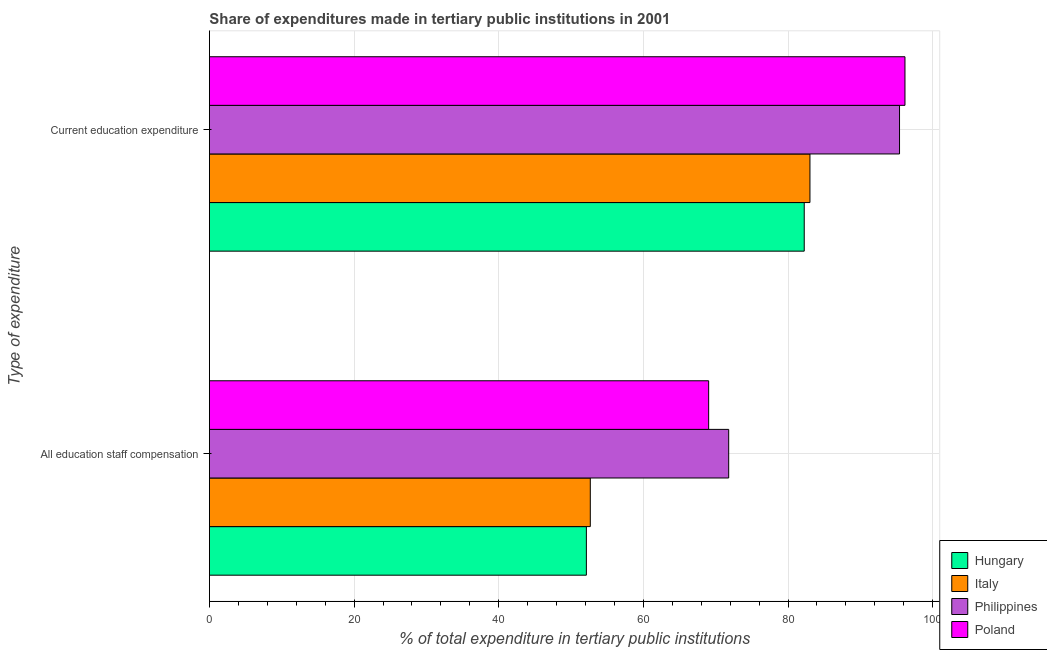How many different coloured bars are there?
Offer a terse response. 4. How many groups of bars are there?
Your answer should be compact. 2. How many bars are there on the 1st tick from the top?
Your response must be concise. 4. What is the label of the 2nd group of bars from the top?
Provide a succinct answer. All education staff compensation. What is the expenditure in staff compensation in Poland?
Offer a terse response. 69.02. Across all countries, what is the maximum expenditure in education?
Offer a very short reply. 96.16. Across all countries, what is the minimum expenditure in education?
Provide a short and direct response. 82.24. In which country was the expenditure in education minimum?
Make the answer very short. Hungary. What is the total expenditure in education in the graph?
Offer a very short reply. 356.84. What is the difference between the expenditure in education in Italy and that in Philippines?
Provide a short and direct response. -12.39. What is the difference between the expenditure in education in Hungary and the expenditure in staff compensation in Poland?
Offer a terse response. 13.22. What is the average expenditure in education per country?
Give a very brief answer. 89.21. What is the difference between the expenditure in staff compensation and expenditure in education in Hungary?
Your answer should be compact. -30.12. In how many countries, is the expenditure in education greater than 16 %?
Keep it short and to the point. 4. What is the ratio of the expenditure in staff compensation in Philippines to that in Poland?
Your response must be concise. 1.04. In how many countries, is the expenditure in staff compensation greater than the average expenditure in staff compensation taken over all countries?
Provide a succinct answer. 2. How many bars are there?
Provide a succinct answer. 8. What is the difference between two consecutive major ticks on the X-axis?
Provide a short and direct response. 20. Are the values on the major ticks of X-axis written in scientific E-notation?
Give a very brief answer. No. Does the graph contain any zero values?
Provide a succinct answer. No. How many legend labels are there?
Your answer should be very brief. 4. How are the legend labels stacked?
Your answer should be very brief. Vertical. What is the title of the graph?
Make the answer very short. Share of expenditures made in tertiary public institutions in 2001. What is the label or title of the X-axis?
Offer a terse response. % of total expenditure in tertiary public institutions. What is the label or title of the Y-axis?
Your answer should be very brief. Type of expenditure. What is the % of total expenditure in tertiary public institutions in Hungary in All education staff compensation?
Make the answer very short. 52.12. What is the % of total expenditure in tertiary public institutions of Italy in All education staff compensation?
Make the answer very short. 52.66. What is the % of total expenditure in tertiary public institutions of Philippines in All education staff compensation?
Give a very brief answer. 71.79. What is the % of total expenditure in tertiary public institutions in Poland in All education staff compensation?
Provide a succinct answer. 69.02. What is the % of total expenditure in tertiary public institutions in Hungary in Current education expenditure?
Your answer should be very brief. 82.24. What is the % of total expenditure in tertiary public institutions of Italy in Current education expenditure?
Provide a short and direct response. 83.03. What is the % of total expenditure in tertiary public institutions of Philippines in Current education expenditure?
Make the answer very short. 95.41. What is the % of total expenditure in tertiary public institutions of Poland in Current education expenditure?
Offer a very short reply. 96.16. Across all Type of expenditure, what is the maximum % of total expenditure in tertiary public institutions in Hungary?
Offer a very short reply. 82.24. Across all Type of expenditure, what is the maximum % of total expenditure in tertiary public institutions in Italy?
Provide a succinct answer. 83.03. Across all Type of expenditure, what is the maximum % of total expenditure in tertiary public institutions of Philippines?
Provide a short and direct response. 95.41. Across all Type of expenditure, what is the maximum % of total expenditure in tertiary public institutions in Poland?
Your answer should be very brief. 96.16. Across all Type of expenditure, what is the minimum % of total expenditure in tertiary public institutions of Hungary?
Offer a very short reply. 52.12. Across all Type of expenditure, what is the minimum % of total expenditure in tertiary public institutions of Italy?
Your response must be concise. 52.66. Across all Type of expenditure, what is the minimum % of total expenditure in tertiary public institutions of Philippines?
Your answer should be very brief. 71.79. Across all Type of expenditure, what is the minimum % of total expenditure in tertiary public institutions in Poland?
Make the answer very short. 69.02. What is the total % of total expenditure in tertiary public institutions of Hungary in the graph?
Make the answer very short. 134.35. What is the total % of total expenditure in tertiary public institutions in Italy in the graph?
Provide a short and direct response. 135.69. What is the total % of total expenditure in tertiary public institutions of Philippines in the graph?
Your response must be concise. 167.21. What is the total % of total expenditure in tertiary public institutions of Poland in the graph?
Your answer should be compact. 165.19. What is the difference between the % of total expenditure in tertiary public institutions in Hungary in All education staff compensation and that in Current education expenditure?
Make the answer very short. -30.12. What is the difference between the % of total expenditure in tertiary public institutions in Italy in All education staff compensation and that in Current education expenditure?
Your response must be concise. -30.37. What is the difference between the % of total expenditure in tertiary public institutions in Philippines in All education staff compensation and that in Current education expenditure?
Ensure brevity in your answer.  -23.62. What is the difference between the % of total expenditure in tertiary public institutions of Poland in All education staff compensation and that in Current education expenditure?
Offer a terse response. -27.14. What is the difference between the % of total expenditure in tertiary public institutions of Hungary in All education staff compensation and the % of total expenditure in tertiary public institutions of Italy in Current education expenditure?
Provide a short and direct response. -30.91. What is the difference between the % of total expenditure in tertiary public institutions in Hungary in All education staff compensation and the % of total expenditure in tertiary public institutions in Philippines in Current education expenditure?
Keep it short and to the point. -43.3. What is the difference between the % of total expenditure in tertiary public institutions in Hungary in All education staff compensation and the % of total expenditure in tertiary public institutions in Poland in Current education expenditure?
Your response must be concise. -44.05. What is the difference between the % of total expenditure in tertiary public institutions of Italy in All education staff compensation and the % of total expenditure in tertiary public institutions of Philippines in Current education expenditure?
Your answer should be compact. -42.75. What is the difference between the % of total expenditure in tertiary public institutions of Italy in All education staff compensation and the % of total expenditure in tertiary public institutions of Poland in Current education expenditure?
Make the answer very short. -43.5. What is the difference between the % of total expenditure in tertiary public institutions of Philippines in All education staff compensation and the % of total expenditure in tertiary public institutions of Poland in Current education expenditure?
Ensure brevity in your answer.  -24.37. What is the average % of total expenditure in tertiary public institutions of Hungary per Type of expenditure?
Offer a very short reply. 67.18. What is the average % of total expenditure in tertiary public institutions of Italy per Type of expenditure?
Your answer should be compact. 67.84. What is the average % of total expenditure in tertiary public institutions of Philippines per Type of expenditure?
Give a very brief answer. 83.6. What is the average % of total expenditure in tertiary public institutions in Poland per Type of expenditure?
Provide a short and direct response. 82.59. What is the difference between the % of total expenditure in tertiary public institutions in Hungary and % of total expenditure in tertiary public institutions in Italy in All education staff compensation?
Offer a terse response. -0.54. What is the difference between the % of total expenditure in tertiary public institutions of Hungary and % of total expenditure in tertiary public institutions of Philippines in All education staff compensation?
Offer a very short reply. -19.67. What is the difference between the % of total expenditure in tertiary public institutions of Hungary and % of total expenditure in tertiary public institutions of Poland in All education staff compensation?
Give a very brief answer. -16.9. What is the difference between the % of total expenditure in tertiary public institutions of Italy and % of total expenditure in tertiary public institutions of Philippines in All education staff compensation?
Ensure brevity in your answer.  -19.13. What is the difference between the % of total expenditure in tertiary public institutions of Italy and % of total expenditure in tertiary public institutions of Poland in All education staff compensation?
Offer a very short reply. -16.36. What is the difference between the % of total expenditure in tertiary public institutions in Philippines and % of total expenditure in tertiary public institutions in Poland in All education staff compensation?
Offer a terse response. 2.77. What is the difference between the % of total expenditure in tertiary public institutions of Hungary and % of total expenditure in tertiary public institutions of Italy in Current education expenditure?
Your answer should be compact. -0.79. What is the difference between the % of total expenditure in tertiary public institutions of Hungary and % of total expenditure in tertiary public institutions of Philippines in Current education expenditure?
Give a very brief answer. -13.18. What is the difference between the % of total expenditure in tertiary public institutions in Hungary and % of total expenditure in tertiary public institutions in Poland in Current education expenditure?
Offer a very short reply. -13.93. What is the difference between the % of total expenditure in tertiary public institutions of Italy and % of total expenditure in tertiary public institutions of Philippines in Current education expenditure?
Provide a short and direct response. -12.39. What is the difference between the % of total expenditure in tertiary public institutions of Italy and % of total expenditure in tertiary public institutions of Poland in Current education expenditure?
Your answer should be very brief. -13.14. What is the difference between the % of total expenditure in tertiary public institutions in Philippines and % of total expenditure in tertiary public institutions in Poland in Current education expenditure?
Provide a short and direct response. -0.75. What is the ratio of the % of total expenditure in tertiary public institutions in Hungary in All education staff compensation to that in Current education expenditure?
Offer a terse response. 0.63. What is the ratio of the % of total expenditure in tertiary public institutions of Italy in All education staff compensation to that in Current education expenditure?
Keep it short and to the point. 0.63. What is the ratio of the % of total expenditure in tertiary public institutions in Philippines in All education staff compensation to that in Current education expenditure?
Keep it short and to the point. 0.75. What is the ratio of the % of total expenditure in tertiary public institutions in Poland in All education staff compensation to that in Current education expenditure?
Provide a short and direct response. 0.72. What is the difference between the highest and the second highest % of total expenditure in tertiary public institutions in Hungary?
Ensure brevity in your answer.  30.12. What is the difference between the highest and the second highest % of total expenditure in tertiary public institutions in Italy?
Your answer should be compact. 30.37. What is the difference between the highest and the second highest % of total expenditure in tertiary public institutions in Philippines?
Keep it short and to the point. 23.62. What is the difference between the highest and the second highest % of total expenditure in tertiary public institutions of Poland?
Your answer should be very brief. 27.14. What is the difference between the highest and the lowest % of total expenditure in tertiary public institutions in Hungary?
Make the answer very short. 30.12. What is the difference between the highest and the lowest % of total expenditure in tertiary public institutions of Italy?
Your answer should be very brief. 30.37. What is the difference between the highest and the lowest % of total expenditure in tertiary public institutions of Philippines?
Your response must be concise. 23.62. What is the difference between the highest and the lowest % of total expenditure in tertiary public institutions of Poland?
Provide a succinct answer. 27.14. 